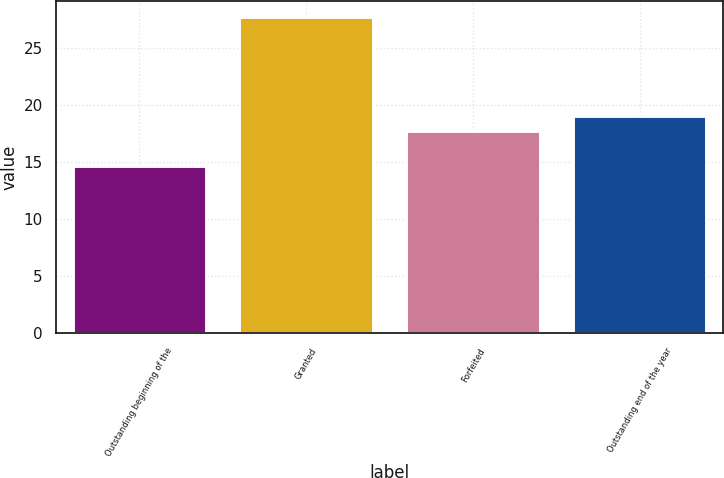Convert chart. <chart><loc_0><loc_0><loc_500><loc_500><bar_chart><fcel>Outstanding beginning of the<fcel>Granted<fcel>Forfeited<fcel>Outstanding end of the year<nl><fcel>14.64<fcel>27.69<fcel>17.74<fcel>19.04<nl></chart> 